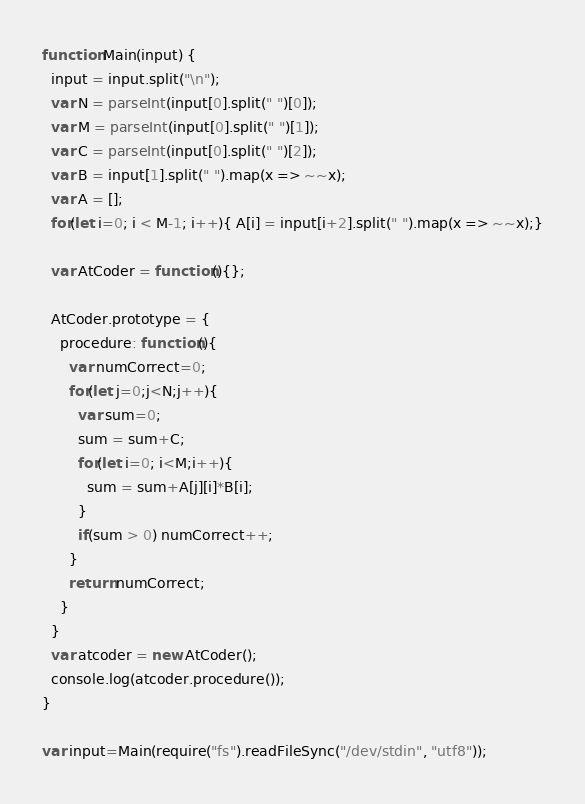Convert code to text. <code><loc_0><loc_0><loc_500><loc_500><_JavaScript_>function Main(input) {
  input = input.split("\n");
  var N = parseInt(input[0].split(" ")[0]);
  var M = parseInt(input[0].split(" ")[1]);
  var C = parseInt(input[0].split(" ")[2]);
  var B = input[1].split(" ").map(x => ~~x);
  var A = [];
  for(let i=0; i < M-1; i++){ A[i] = input[i+2].split(" ").map(x => ~~x);}

  var AtCoder = function(){};

  AtCoder.prototype = {
    procedure: function(){
      var numCorrect=0;
      for(let j=0;j<N;j++){
        var sum=0;
        sum = sum+C;
        for(let i=0; i<M;i++){
          sum = sum+A[j][i]*B[i];
        }
        if(sum > 0) numCorrect++;
      }
      return numCorrect;
    }
  }
  var atcoder = new AtCoder();
  console.log(atcoder.procedure());
}

var input=Main(require("fs").readFileSync("/dev/stdin", "utf8"));</code> 